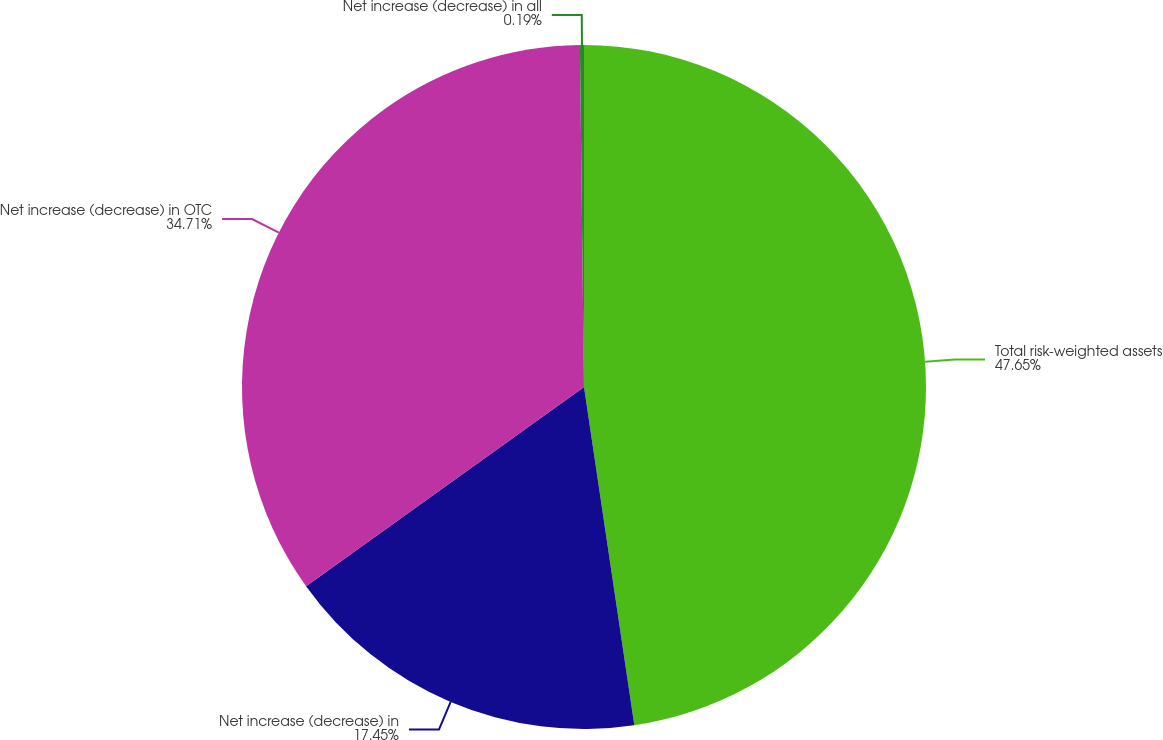Convert chart to OTSL. <chart><loc_0><loc_0><loc_500><loc_500><pie_chart><fcel>Total risk-weighted assets<fcel>Net increase (decrease) in<fcel>Net increase (decrease) in OTC<fcel>Net increase (decrease) in all<nl><fcel>47.65%<fcel>17.45%<fcel>34.71%<fcel>0.19%<nl></chart> 